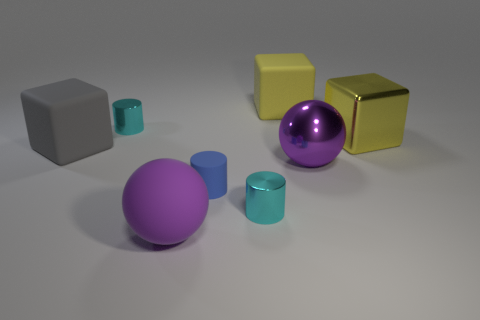Add 2 tiny cyan metal objects. How many objects exist? 10 Subtract all balls. How many objects are left? 6 Add 3 big yellow blocks. How many big yellow blocks exist? 5 Subtract 0 yellow balls. How many objects are left? 8 Subtract all cyan blocks. Subtract all big purple metallic spheres. How many objects are left? 7 Add 6 tiny blue rubber things. How many tiny blue rubber things are left? 7 